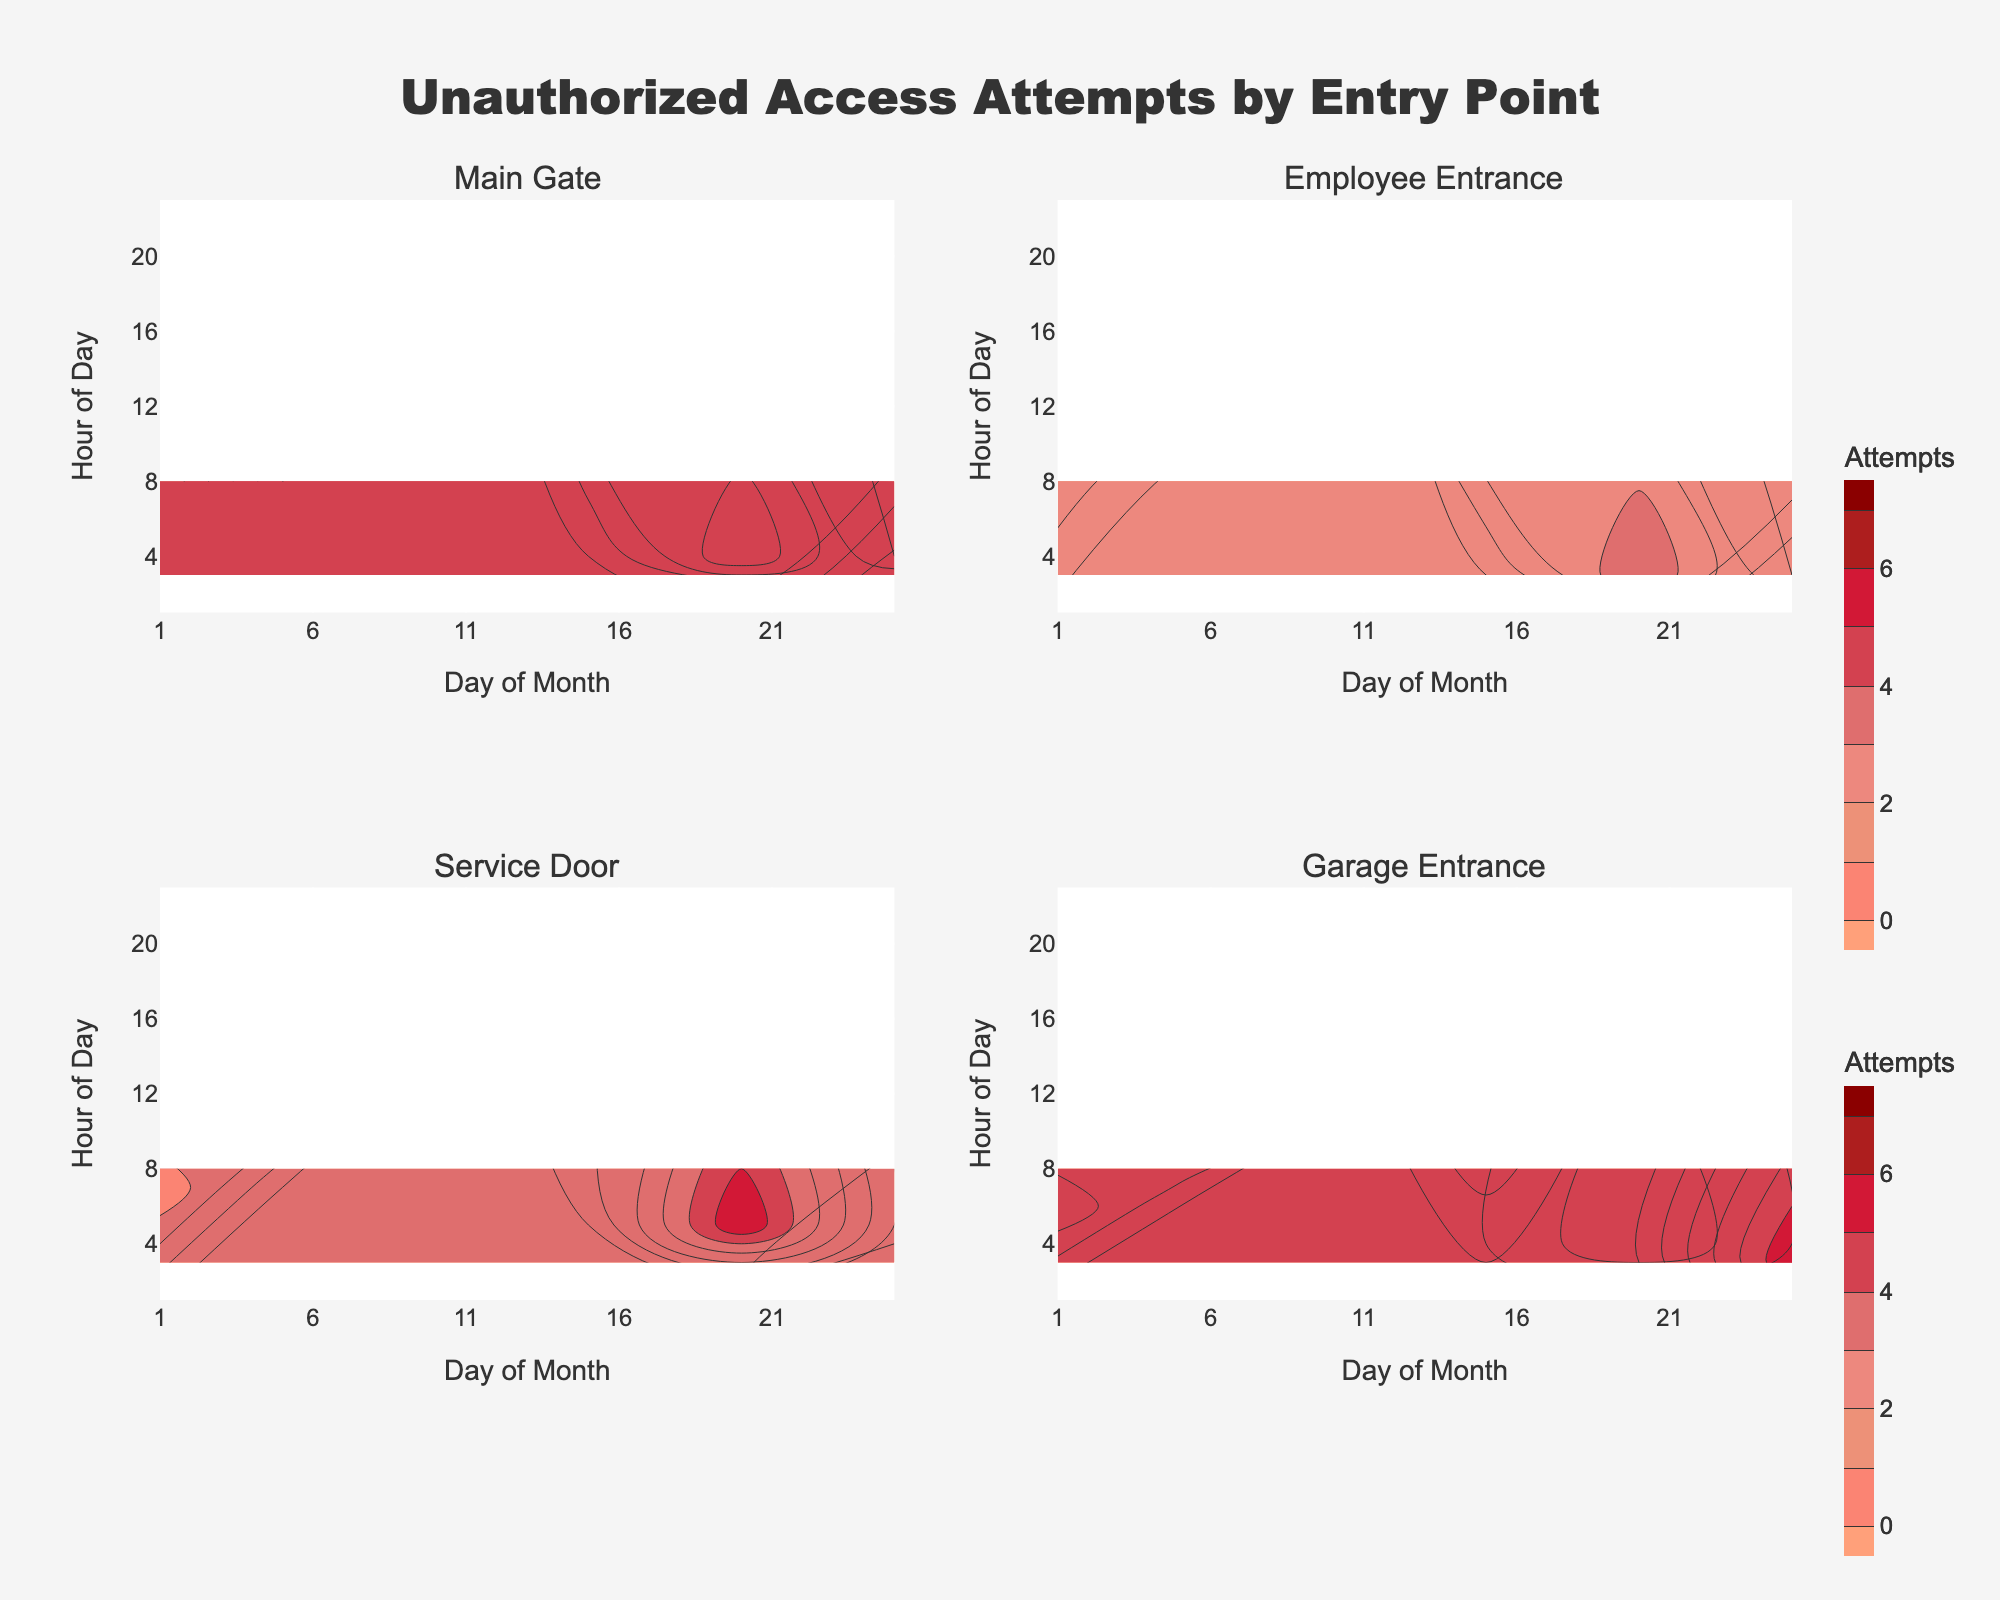What is the title of the contour plot? The title is displayed prominently at the top center of the figure. By reading it directly, the title can be identified.
Answer: Unauthorized Access Attempts by Entry Point How many entry points are analyzed in the plot? Each subplot represents one entry point. There are four subplots in a 2x2 grid.
Answer: 4 At which hour of the day is the highest number of unauthorized access attempts observed across any entry point? By inspecting the contours, we can see that the peak for any entry point occurs at the Employee Entrance at the 21st hour (21:00) on the 15th day.
Answer: 21:00 Which entry point shows the most frequent unauthorized access attempts at midnight? By examining the contours at the hour corresponding to midnight (00:00), we note the most frequent attempts at the Employee Entrance.
Answer: Employee Entrance Which entry point had the maximum unauthorized access attempts, and how many attempts were there at this peak? By observing the highest contour levels across all subplots, the Employee Entrance had the peak access attempts of 7, documented on the 15th day at 21:00.
Answer: Employee Entrance, 7 On which day did the Main Gate experience its highest number of access attempts, and what time was it? Reviewing the contours of the Main Gate subplot reveals the highest attempt of 6 at 22:00 on the 15th day.
Answer: 15th day, 22:00 Compare the contours of the Service Door and the Garage Entrance. Which one has a higher overall concentration of unauthorized access attempts? By visually inspecting the density of the contour lines, it can be noted that the Garage Entrance shows a higher concentration of attempts than the Service Door, especially around the 25th day.
Answer: Garage Entrance Did any entry point report more access attempts at noon compared to midnight? By analyzing the contour lines at hours corresponding to noon (12:00) and midnight (00:00), we see that no entry point reports more attempts at noon compared to midnight.
Answer: No Which days show a noticeable increase in unauthorized access attempts across all the entry points? By looking at the contour lines for each subplot, there are noticeable increases on the 15th and the 25th day for all entry points.
Answer: 15th and 25th days 